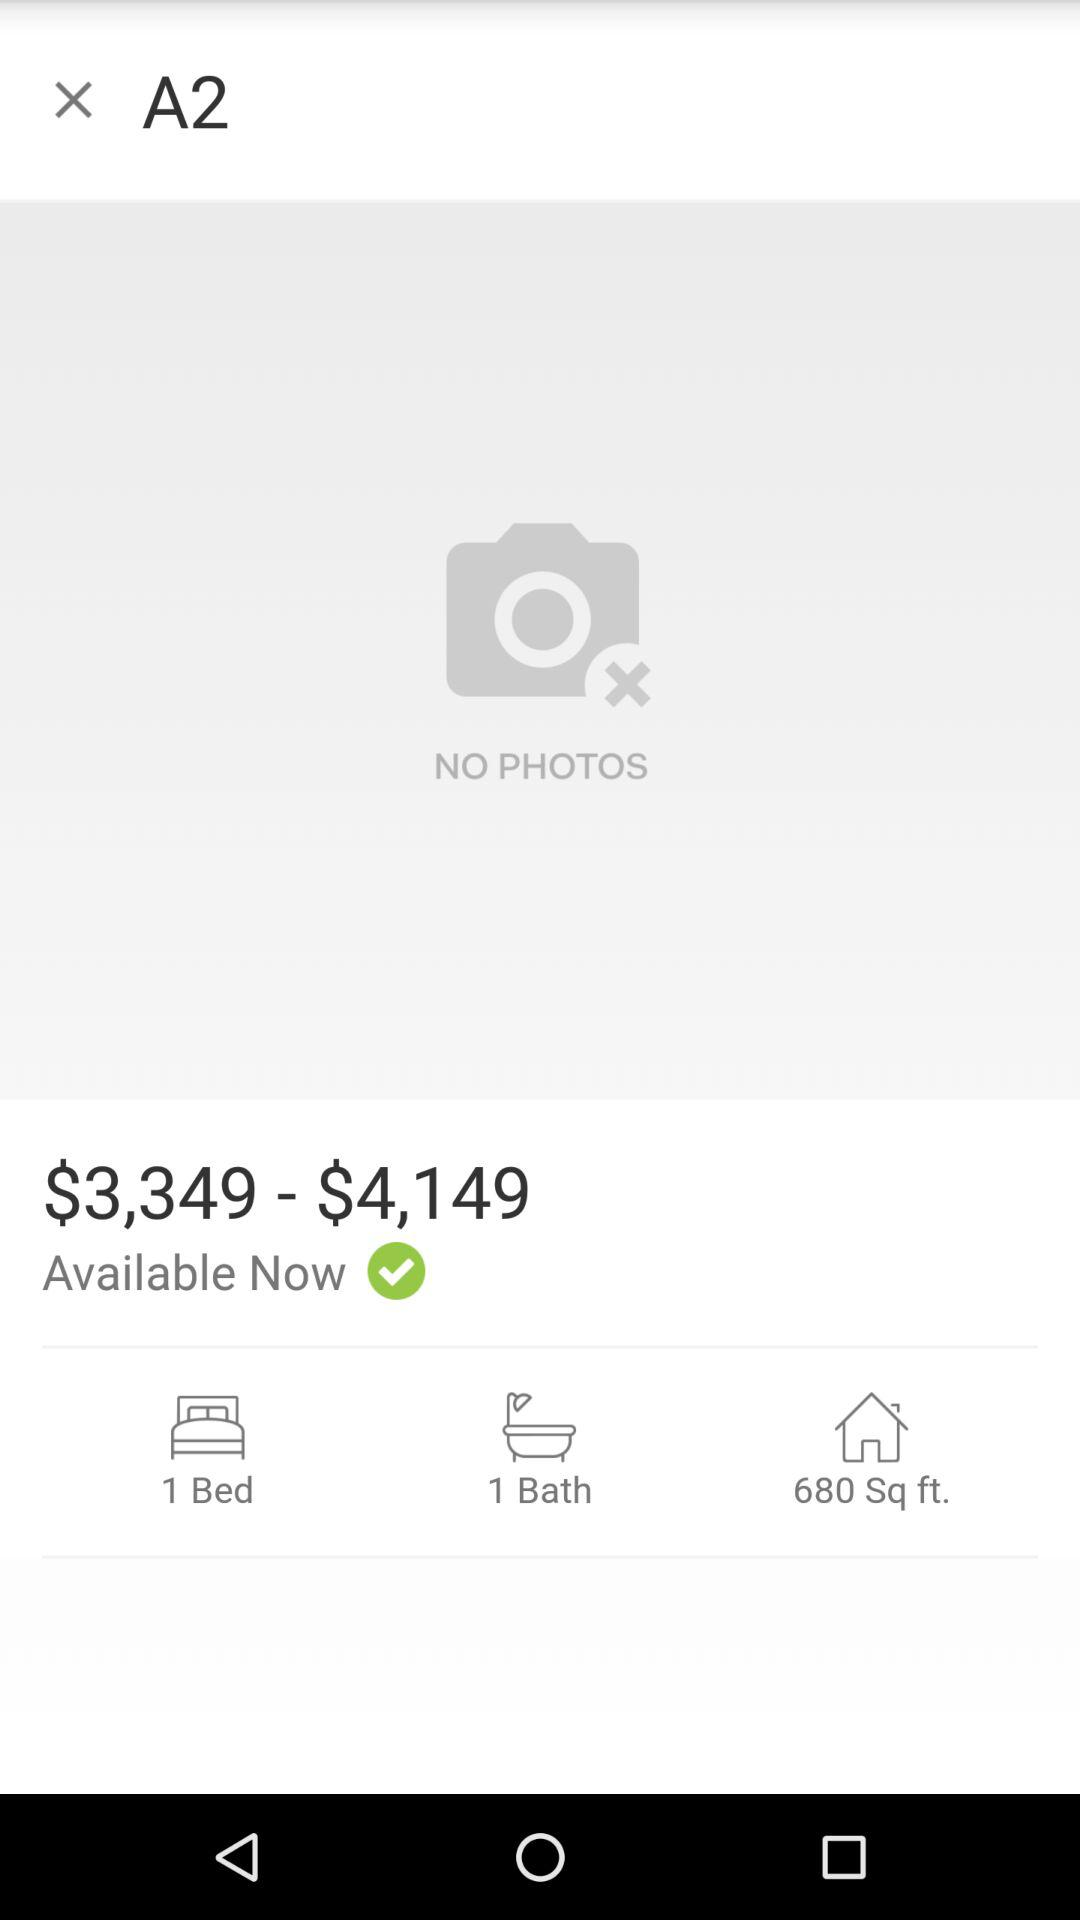What is the amount? The amount ranges from $3349 to $4149. 